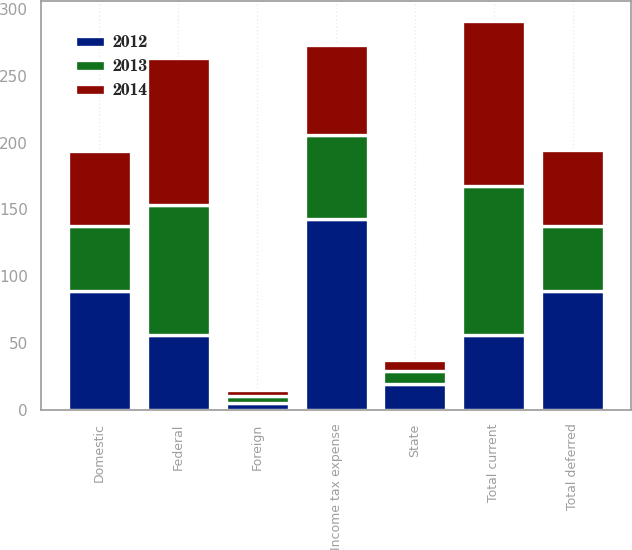Convert chart to OTSL. <chart><loc_0><loc_0><loc_500><loc_500><stacked_bar_chart><ecel><fcel>Federal<fcel>State<fcel>Foreign<fcel>Total current<fcel>Domestic<fcel>Total deferred<fcel>Income tax expense<nl><fcel>2012<fcel>56.3<fcel>19.3<fcel>5.8<fcel>56.3<fcel>89<fcel>89.1<fcel>142.8<nl><fcel>2013<fcel>96.7<fcel>10.1<fcel>4.6<fcel>111.4<fcel>48.6<fcel>48.7<fcel>62.7<nl><fcel>2014<fcel>110.3<fcel>8<fcel>5.1<fcel>123.4<fcel>56.2<fcel>56.3<fcel>67.1<nl></chart> 